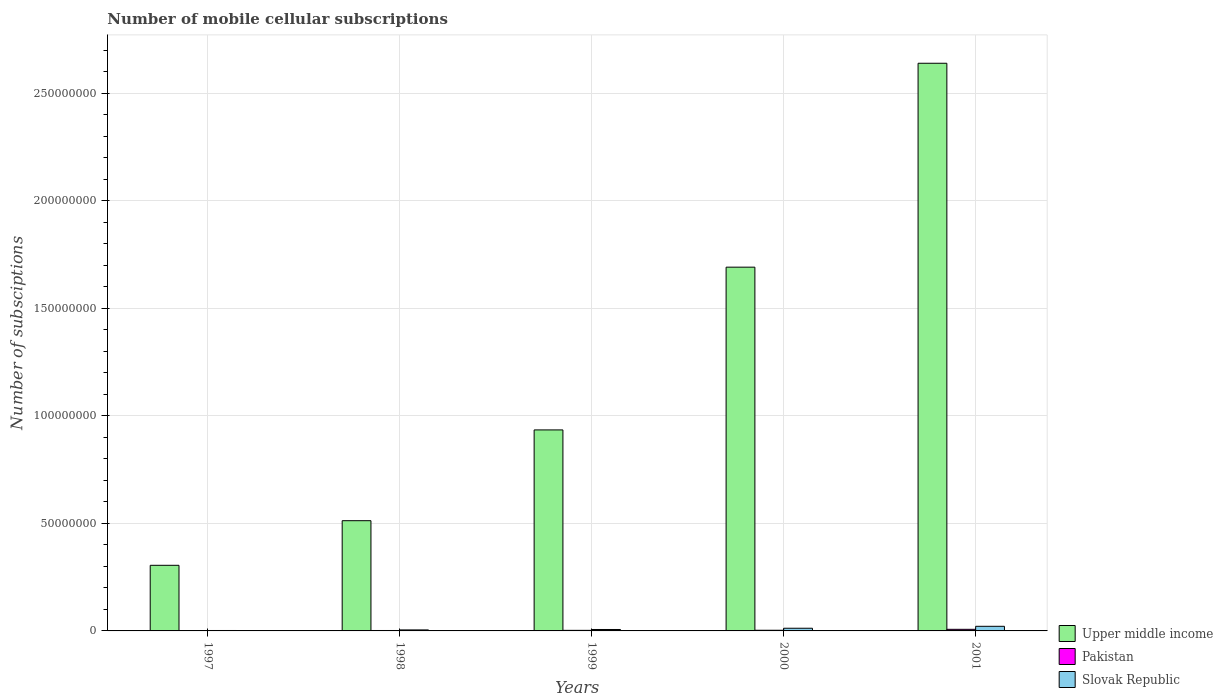How many different coloured bars are there?
Ensure brevity in your answer.  3. How many groups of bars are there?
Give a very brief answer. 5. How many bars are there on the 5th tick from the left?
Give a very brief answer. 3. How many bars are there on the 3rd tick from the right?
Provide a short and direct response. 3. What is the label of the 1st group of bars from the left?
Your answer should be compact. 1997. In how many cases, is the number of bars for a given year not equal to the number of legend labels?
Ensure brevity in your answer.  0. What is the number of mobile cellular subscriptions in Slovak Republic in 2000?
Ensure brevity in your answer.  1.24e+06. Across all years, what is the maximum number of mobile cellular subscriptions in Upper middle income?
Make the answer very short. 2.64e+08. Across all years, what is the minimum number of mobile cellular subscriptions in Slovak Republic?
Give a very brief answer. 2.00e+05. In which year was the number of mobile cellular subscriptions in Slovak Republic maximum?
Keep it short and to the point. 2001. What is the total number of mobile cellular subscriptions in Slovak Republic in the graph?
Your answer should be compact. 4.72e+06. What is the difference between the number of mobile cellular subscriptions in Upper middle income in 1998 and that in 1999?
Provide a short and direct response. -4.22e+07. What is the difference between the number of mobile cellular subscriptions in Slovak Republic in 1997 and the number of mobile cellular subscriptions in Pakistan in 2001?
Your answer should be compact. -5.42e+05. What is the average number of mobile cellular subscriptions in Upper middle income per year?
Provide a succinct answer. 1.22e+08. In the year 1997, what is the difference between the number of mobile cellular subscriptions in Pakistan and number of mobile cellular subscriptions in Upper middle income?
Provide a short and direct response. -3.04e+07. In how many years, is the number of mobile cellular subscriptions in Slovak Republic greater than 80000000?
Your response must be concise. 0. What is the ratio of the number of mobile cellular subscriptions in Slovak Republic in 1997 to that in 2000?
Your answer should be very brief. 0.16. What is the difference between the highest and the second highest number of mobile cellular subscriptions in Pakistan?
Your answer should be compact. 4.36e+05. What is the difference between the highest and the lowest number of mobile cellular subscriptions in Upper middle income?
Offer a terse response. 2.33e+08. Is the sum of the number of mobile cellular subscriptions in Upper middle income in 1997 and 1998 greater than the maximum number of mobile cellular subscriptions in Slovak Republic across all years?
Ensure brevity in your answer.  Yes. What does the 3rd bar from the left in 2000 represents?
Offer a very short reply. Slovak Republic. What does the 3rd bar from the right in 1998 represents?
Ensure brevity in your answer.  Upper middle income. Is it the case that in every year, the sum of the number of mobile cellular subscriptions in Slovak Republic and number of mobile cellular subscriptions in Pakistan is greater than the number of mobile cellular subscriptions in Upper middle income?
Your answer should be compact. No. Are all the bars in the graph horizontal?
Provide a succinct answer. No. Does the graph contain any zero values?
Make the answer very short. No. How many legend labels are there?
Your answer should be compact. 3. What is the title of the graph?
Provide a succinct answer. Number of mobile cellular subscriptions. Does "Rwanda" appear as one of the legend labels in the graph?
Offer a very short reply. No. What is the label or title of the X-axis?
Your response must be concise. Years. What is the label or title of the Y-axis?
Offer a very short reply. Number of subsciptions. What is the Number of subsciptions of Upper middle income in 1997?
Provide a succinct answer. 3.05e+07. What is the Number of subsciptions in Pakistan in 1997?
Your response must be concise. 1.35e+05. What is the Number of subsciptions in Slovak Republic in 1997?
Keep it short and to the point. 2.00e+05. What is the Number of subsciptions in Upper middle income in 1998?
Make the answer very short. 5.12e+07. What is the Number of subsciptions in Pakistan in 1998?
Your response must be concise. 1.96e+05. What is the Number of subsciptions in Slovak Republic in 1998?
Your answer should be very brief. 4.65e+05. What is the Number of subsciptions in Upper middle income in 1999?
Your answer should be very brief. 9.35e+07. What is the Number of subsciptions of Pakistan in 1999?
Provide a succinct answer. 2.66e+05. What is the Number of subsciptions in Slovak Republic in 1999?
Provide a short and direct response. 6.64e+05. What is the Number of subsciptions of Upper middle income in 2000?
Provide a short and direct response. 1.69e+08. What is the Number of subsciptions of Pakistan in 2000?
Your response must be concise. 3.06e+05. What is the Number of subsciptions in Slovak Republic in 2000?
Provide a short and direct response. 1.24e+06. What is the Number of subsciptions of Upper middle income in 2001?
Keep it short and to the point. 2.64e+08. What is the Number of subsciptions of Pakistan in 2001?
Keep it short and to the point. 7.43e+05. What is the Number of subsciptions in Slovak Republic in 2001?
Your response must be concise. 2.15e+06. Across all years, what is the maximum Number of subsciptions in Upper middle income?
Your response must be concise. 2.64e+08. Across all years, what is the maximum Number of subsciptions of Pakistan?
Provide a short and direct response. 7.43e+05. Across all years, what is the maximum Number of subsciptions of Slovak Republic?
Provide a short and direct response. 2.15e+06. Across all years, what is the minimum Number of subsciptions of Upper middle income?
Keep it short and to the point. 3.05e+07. Across all years, what is the minimum Number of subsciptions in Pakistan?
Your answer should be compact. 1.35e+05. Across all years, what is the minimum Number of subsciptions of Slovak Republic?
Offer a very short reply. 2.00e+05. What is the total Number of subsciptions of Upper middle income in the graph?
Your answer should be very brief. 6.08e+08. What is the total Number of subsciptions of Pakistan in the graph?
Provide a short and direct response. 1.65e+06. What is the total Number of subsciptions in Slovak Republic in the graph?
Ensure brevity in your answer.  4.72e+06. What is the difference between the Number of subsciptions of Upper middle income in 1997 and that in 1998?
Provide a succinct answer. -2.07e+07. What is the difference between the Number of subsciptions in Pakistan in 1997 and that in 1998?
Ensure brevity in your answer.  -6.11e+04. What is the difference between the Number of subsciptions in Slovak Republic in 1997 and that in 1998?
Offer a terse response. -2.65e+05. What is the difference between the Number of subsciptions in Upper middle income in 1997 and that in 1999?
Your answer should be compact. -6.29e+07. What is the difference between the Number of subsciptions in Pakistan in 1997 and that in 1999?
Offer a very short reply. -1.31e+05. What is the difference between the Number of subsciptions in Slovak Republic in 1997 and that in 1999?
Offer a terse response. -4.64e+05. What is the difference between the Number of subsciptions in Upper middle income in 1997 and that in 2000?
Keep it short and to the point. -1.39e+08. What is the difference between the Number of subsciptions in Pakistan in 1997 and that in 2000?
Offer a very short reply. -1.71e+05. What is the difference between the Number of subsciptions of Slovak Republic in 1997 and that in 2000?
Give a very brief answer. -1.04e+06. What is the difference between the Number of subsciptions in Upper middle income in 1997 and that in 2001?
Ensure brevity in your answer.  -2.33e+08. What is the difference between the Number of subsciptions of Pakistan in 1997 and that in 2001?
Your response must be concise. -6.08e+05. What is the difference between the Number of subsciptions of Slovak Republic in 1997 and that in 2001?
Offer a terse response. -1.95e+06. What is the difference between the Number of subsciptions in Upper middle income in 1998 and that in 1999?
Provide a short and direct response. -4.22e+07. What is the difference between the Number of subsciptions of Pakistan in 1998 and that in 1999?
Your answer should be very brief. -6.95e+04. What is the difference between the Number of subsciptions in Slovak Republic in 1998 and that in 1999?
Offer a very short reply. -1.99e+05. What is the difference between the Number of subsciptions in Upper middle income in 1998 and that in 2000?
Provide a short and direct response. -1.18e+08. What is the difference between the Number of subsciptions in Pakistan in 1998 and that in 2000?
Your response must be concise. -1.10e+05. What is the difference between the Number of subsciptions in Slovak Republic in 1998 and that in 2000?
Your answer should be very brief. -7.78e+05. What is the difference between the Number of subsciptions in Upper middle income in 1998 and that in 2001?
Give a very brief answer. -2.13e+08. What is the difference between the Number of subsciptions of Pakistan in 1998 and that in 2001?
Your answer should be very brief. -5.47e+05. What is the difference between the Number of subsciptions in Slovak Republic in 1998 and that in 2001?
Provide a succinct answer. -1.68e+06. What is the difference between the Number of subsciptions in Upper middle income in 1999 and that in 2000?
Your answer should be compact. -7.57e+07. What is the difference between the Number of subsciptions in Pakistan in 1999 and that in 2000?
Give a very brief answer. -4.09e+04. What is the difference between the Number of subsciptions of Slovak Republic in 1999 and that in 2000?
Keep it short and to the point. -5.80e+05. What is the difference between the Number of subsciptions in Upper middle income in 1999 and that in 2001?
Make the answer very short. -1.70e+08. What is the difference between the Number of subsciptions in Pakistan in 1999 and that in 2001?
Provide a succinct answer. -4.77e+05. What is the difference between the Number of subsciptions of Slovak Republic in 1999 and that in 2001?
Keep it short and to the point. -1.48e+06. What is the difference between the Number of subsciptions in Upper middle income in 2000 and that in 2001?
Provide a short and direct response. -9.48e+07. What is the difference between the Number of subsciptions of Pakistan in 2000 and that in 2001?
Provide a short and direct response. -4.36e+05. What is the difference between the Number of subsciptions in Slovak Republic in 2000 and that in 2001?
Offer a very short reply. -9.04e+05. What is the difference between the Number of subsciptions in Upper middle income in 1997 and the Number of subsciptions in Pakistan in 1998?
Your answer should be compact. 3.03e+07. What is the difference between the Number of subsciptions in Upper middle income in 1997 and the Number of subsciptions in Slovak Republic in 1998?
Your answer should be compact. 3.00e+07. What is the difference between the Number of subsciptions of Pakistan in 1997 and the Number of subsciptions of Slovak Republic in 1998?
Offer a very short reply. -3.30e+05. What is the difference between the Number of subsciptions in Upper middle income in 1997 and the Number of subsciptions in Pakistan in 1999?
Provide a succinct answer. 3.02e+07. What is the difference between the Number of subsciptions in Upper middle income in 1997 and the Number of subsciptions in Slovak Republic in 1999?
Make the answer very short. 2.98e+07. What is the difference between the Number of subsciptions of Pakistan in 1997 and the Number of subsciptions of Slovak Republic in 1999?
Your answer should be very brief. -5.29e+05. What is the difference between the Number of subsciptions of Upper middle income in 1997 and the Number of subsciptions of Pakistan in 2000?
Keep it short and to the point. 3.02e+07. What is the difference between the Number of subsciptions of Upper middle income in 1997 and the Number of subsciptions of Slovak Republic in 2000?
Ensure brevity in your answer.  2.93e+07. What is the difference between the Number of subsciptions in Pakistan in 1997 and the Number of subsciptions in Slovak Republic in 2000?
Provide a short and direct response. -1.11e+06. What is the difference between the Number of subsciptions in Upper middle income in 1997 and the Number of subsciptions in Pakistan in 2001?
Provide a succinct answer. 2.98e+07. What is the difference between the Number of subsciptions of Upper middle income in 1997 and the Number of subsciptions of Slovak Republic in 2001?
Ensure brevity in your answer.  2.84e+07. What is the difference between the Number of subsciptions in Pakistan in 1997 and the Number of subsciptions in Slovak Republic in 2001?
Offer a very short reply. -2.01e+06. What is the difference between the Number of subsciptions in Upper middle income in 1998 and the Number of subsciptions in Pakistan in 1999?
Provide a short and direct response. 5.10e+07. What is the difference between the Number of subsciptions in Upper middle income in 1998 and the Number of subsciptions in Slovak Republic in 1999?
Offer a very short reply. 5.06e+07. What is the difference between the Number of subsciptions in Pakistan in 1998 and the Number of subsciptions in Slovak Republic in 1999?
Offer a very short reply. -4.68e+05. What is the difference between the Number of subsciptions of Upper middle income in 1998 and the Number of subsciptions of Pakistan in 2000?
Your answer should be very brief. 5.09e+07. What is the difference between the Number of subsciptions in Upper middle income in 1998 and the Number of subsciptions in Slovak Republic in 2000?
Your answer should be very brief. 5.00e+07. What is the difference between the Number of subsciptions of Pakistan in 1998 and the Number of subsciptions of Slovak Republic in 2000?
Provide a succinct answer. -1.05e+06. What is the difference between the Number of subsciptions of Upper middle income in 1998 and the Number of subsciptions of Pakistan in 2001?
Keep it short and to the point. 5.05e+07. What is the difference between the Number of subsciptions in Upper middle income in 1998 and the Number of subsciptions in Slovak Republic in 2001?
Provide a succinct answer. 4.91e+07. What is the difference between the Number of subsciptions in Pakistan in 1998 and the Number of subsciptions in Slovak Republic in 2001?
Offer a very short reply. -1.95e+06. What is the difference between the Number of subsciptions of Upper middle income in 1999 and the Number of subsciptions of Pakistan in 2000?
Your answer should be very brief. 9.31e+07. What is the difference between the Number of subsciptions of Upper middle income in 1999 and the Number of subsciptions of Slovak Republic in 2000?
Keep it short and to the point. 9.22e+07. What is the difference between the Number of subsciptions of Pakistan in 1999 and the Number of subsciptions of Slovak Republic in 2000?
Offer a terse response. -9.78e+05. What is the difference between the Number of subsciptions in Upper middle income in 1999 and the Number of subsciptions in Pakistan in 2001?
Keep it short and to the point. 9.27e+07. What is the difference between the Number of subsciptions of Upper middle income in 1999 and the Number of subsciptions of Slovak Republic in 2001?
Offer a terse response. 9.13e+07. What is the difference between the Number of subsciptions in Pakistan in 1999 and the Number of subsciptions in Slovak Republic in 2001?
Offer a terse response. -1.88e+06. What is the difference between the Number of subsciptions of Upper middle income in 2000 and the Number of subsciptions of Pakistan in 2001?
Offer a very short reply. 1.68e+08. What is the difference between the Number of subsciptions in Upper middle income in 2000 and the Number of subsciptions in Slovak Republic in 2001?
Make the answer very short. 1.67e+08. What is the difference between the Number of subsciptions in Pakistan in 2000 and the Number of subsciptions in Slovak Republic in 2001?
Offer a very short reply. -1.84e+06. What is the average Number of subsciptions of Upper middle income per year?
Provide a succinct answer. 1.22e+08. What is the average Number of subsciptions of Pakistan per year?
Make the answer very short. 3.29e+05. What is the average Number of subsciptions of Slovak Republic per year?
Ensure brevity in your answer.  9.44e+05. In the year 1997, what is the difference between the Number of subsciptions of Upper middle income and Number of subsciptions of Pakistan?
Your answer should be very brief. 3.04e+07. In the year 1997, what is the difference between the Number of subsciptions in Upper middle income and Number of subsciptions in Slovak Republic?
Your answer should be very brief. 3.03e+07. In the year 1997, what is the difference between the Number of subsciptions of Pakistan and Number of subsciptions of Slovak Republic?
Make the answer very short. -6.51e+04. In the year 1998, what is the difference between the Number of subsciptions of Upper middle income and Number of subsciptions of Pakistan?
Your answer should be very brief. 5.11e+07. In the year 1998, what is the difference between the Number of subsciptions of Upper middle income and Number of subsciptions of Slovak Republic?
Provide a succinct answer. 5.08e+07. In the year 1998, what is the difference between the Number of subsciptions in Pakistan and Number of subsciptions in Slovak Republic?
Give a very brief answer. -2.69e+05. In the year 1999, what is the difference between the Number of subsciptions of Upper middle income and Number of subsciptions of Pakistan?
Offer a terse response. 9.32e+07. In the year 1999, what is the difference between the Number of subsciptions in Upper middle income and Number of subsciptions in Slovak Republic?
Give a very brief answer. 9.28e+07. In the year 1999, what is the difference between the Number of subsciptions in Pakistan and Number of subsciptions in Slovak Republic?
Your response must be concise. -3.98e+05. In the year 2000, what is the difference between the Number of subsciptions of Upper middle income and Number of subsciptions of Pakistan?
Your answer should be very brief. 1.69e+08. In the year 2000, what is the difference between the Number of subsciptions of Upper middle income and Number of subsciptions of Slovak Republic?
Give a very brief answer. 1.68e+08. In the year 2000, what is the difference between the Number of subsciptions of Pakistan and Number of subsciptions of Slovak Republic?
Your response must be concise. -9.37e+05. In the year 2001, what is the difference between the Number of subsciptions in Upper middle income and Number of subsciptions in Pakistan?
Keep it short and to the point. 2.63e+08. In the year 2001, what is the difference between the Number of subsciptions in Upper middle income and Number of subsciptions in Slovak Republic?
Your response must be concise. 2.62e+08. In the year 2001, what is the difference between the Number of subsciptions in Pakistan and Number of subsciptions in Slovak Republic?
Offer a very short reply. -1.40e+06. What is the ratio of the Number of subsciptions of Upper middle income in 1997 to that in 1998?
Provide a succinct answer. 0.6. What is the ratio of the Number of subsciptions of Pakistan in 1997 to that in 1998?
Make the answer very short. 0.69. What is the ratio of the Number of subsciptions of Slovak Republic in 1997 to that in 1998?
Keep it short and to the point. 0.43. What is the ratio of the Number of subsciptions of Upper middle income in 1997 to that in 1999?
Make the answer very short. 0.33. What is the ratio of the Number of subsciptions in Pakistan in 1997 to that in 1999?
Ensure brevity in your answer.  0.51. What is the ratio of the Number of subsciptions in Slovak Republic in 1997 to that in 1999?
Give a very brief answer. 0.3. What is the ratio of the Number of subsciptions in Upper middle income in 1997 to that in 2000?
Provide a short and direct response. 0.18. What is the ratio of the Number of subsciptions of Pakistan in 1997 to that in 2000?
Offer a terse response. 0.44. What is the ratio of the Number of subsciptions of Slovak Republic in 1997 to that in 2000?
Your answer should be very brief. 0.16. What is the ratio of the Number of subsciptions of Upper middle income in 1997 to that in 2001?
Your answer should be very brief. 0.12. What is the ratio of the Number of subsciptions in Pakistan in 1997 to that in 2001?
Offer a terse response. 0.18. What is the ratio of the Number of subsciptions in Slovak Republic in 1997 to that in 2001?
Make the answer very short. 0.09. What is the ratio of the Number of subsciptions of Upper middle income in 1998 to that in 1999?
Offer a terse response. 0.55. What is the ratio of the Number of subsciptions in Pakistan in 1998 to that in 1999?
Keep it short and to the point. 0.74. What is the ratio of the Number of subsciptions of Slovak Republic in 1998 to that in 1999?
Your response must be concise. 0.7. What is the ratio of the Number of subsciptions in Upper middle income in 1998 to that in 2000?
Your answer should be very brief. 0.3. What is the ratio of the Number of subsciptions of Pakistan in 1998 to that in 2000?
Your answer should be very brief. 0.64. What is the ratio of the Number of subsciptions of Slovak Republic in 1998 to that in 2000?
Your answer should be very brief. 0.37. What is the ratio of the Number of subsciptions in Upper middle income in 1998 to that in 2001?
Provide a short and direct response. 0.19. What is the ratio of the Number of subsciptions of Pakistan in 1998 to that in 2001?
Provide a short and direct response. 0.26. What is the ratio of the Number of subsciptions of Slovak Republic in 1998 to that in 2001?
Your response must be concise. 0.22. What is the ratio of the Number of subsciptions of Upper middle income in 1999 to that in 2000?
Provide a succinct answer. 0.55. What is the ratio of the Number of subsciptions of Pakistan in 1999 to that in 2000?
Your answer should be very brief. 0.87. What is the ratio of the Number of subsciptions of Slovak Republic in 1999 to that in 2000?
Provide a short and direct response. 0.53. What is the ratio of the Number of subsciptions of Upper middle income in 1999 to that in 2001?
Your answer should be very brief. 0.35. What is the ratio of the Number of subsciptions of Pakistan in 1999 to that in 2001?
Your answer should be compact. 0.36. What is the ratio of the Number of subsciptions in Slovak Republic in 1999 to that in 2001?
Offer a terse response. 0.31. What is the ratio of the Number of subsciptions of Upper middle income in 2000 to that in 2001?
Provide a succinct answer. 0.64. What is the ratio of the Number of subsciptions of Pakistan in 2000 to that in 2001?
Provide a succinct answer. 0.41. What is the ratio of the Number of subsciptions of Slovak Republic in 2000 to that in 2001?
Your answer should be very brief. 0.58. What is the difference between the highest and the second highest Number of subsciptions of Upper middle income?
Provide a succinct answer. 9.48e+07. What is the difference between the highest and the second highest Number of subsciptions of Pakistan?
Your response must be concise. 4.36e+05. What is the difference between the highest and the second highest Number of subsciptions of Slovak Republic?
Ensure brevity in your answer.  9.04e+05. What is the difference between the highest and the lowest Number of subsciptions in Upper middle income?
Keep it short and to the point. 2.33e+08. What is the difference between the highest and the lowest Number of subsciptions in Pakistan?
Your response must be concise. 6.08e+05. What is the difference between the highest and the lowest Number of subsciptions in Slovak Republic?
Offer a terse response. 1.95e+06. 